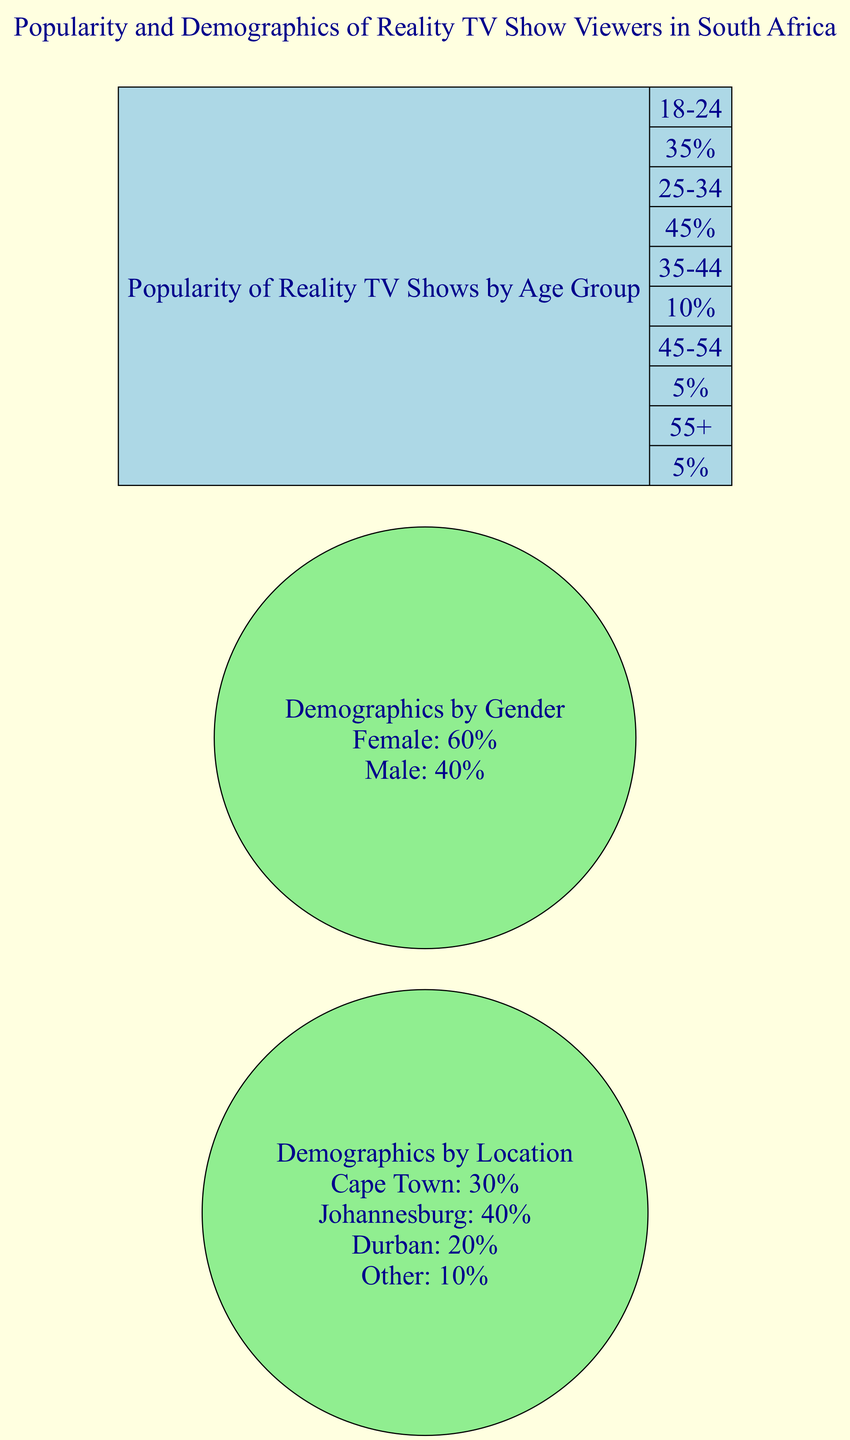What is the popularity percentage of reality TV shows for the age group 25-34? The bar chart shows that the popularity for the age group 25-34 is represented with a value of 45%. This is referenced directly from the bar chart data for that specific age group.
Answer: 45% Which gender demographic has a higher percentage of reality TV show viewers? The pie chart comparing demographics by gender indicates that females make up 60% of the viewers, while males account for 40%. Thus, females have a higher percentage.
Answer: Female In which location is the percentage of reality TV viewers the highest? The pie chart representing demographics by location shows that Johannesburg has the highest percentage, with 40%. This is obtained by comparing all the location percentages from the pie chart.
Answer: Johannesburg What is the total number of age groups represented in the bar chart? The bar chart includes age groups ranging from 18-24, 25-34, 35-44, 45-54, to 55+. Counting these groups gives a total of five age groups represented.
Answer: 5 What is the popularity percentage of reality TV shows for those aged 55 and older? In the bar chart, the age group of 55+ shows a popularity percentage of 5%. This value is directly noted from the bar chart data.
Answer: 5% Which city has the lowest representation of reality TV viewers? Looking at the pie chart by location, 'Other' shows the lowest representation with a percentage of 10%. This is gathered by reviewing all the location data and finding the smallest value.
Answer: Other What percentage of reality TV viewers are male? The demographics pie chart indicates that the male percentage is 40%. This number represents the proportion of male viewers specifically mentioned in the data for that pie chart.
Answer: 40% What is the combined popularity percentage of reality TV shows for the age groups 18-24 and 25-34? The combined popularity can be calculated by adding the popularity percentages from both age groups: 35% (18-24) + 45% (25-34) = 80%. This involves taking the individual values from the bar chart and performing a simple summation.
Answer: 80% 